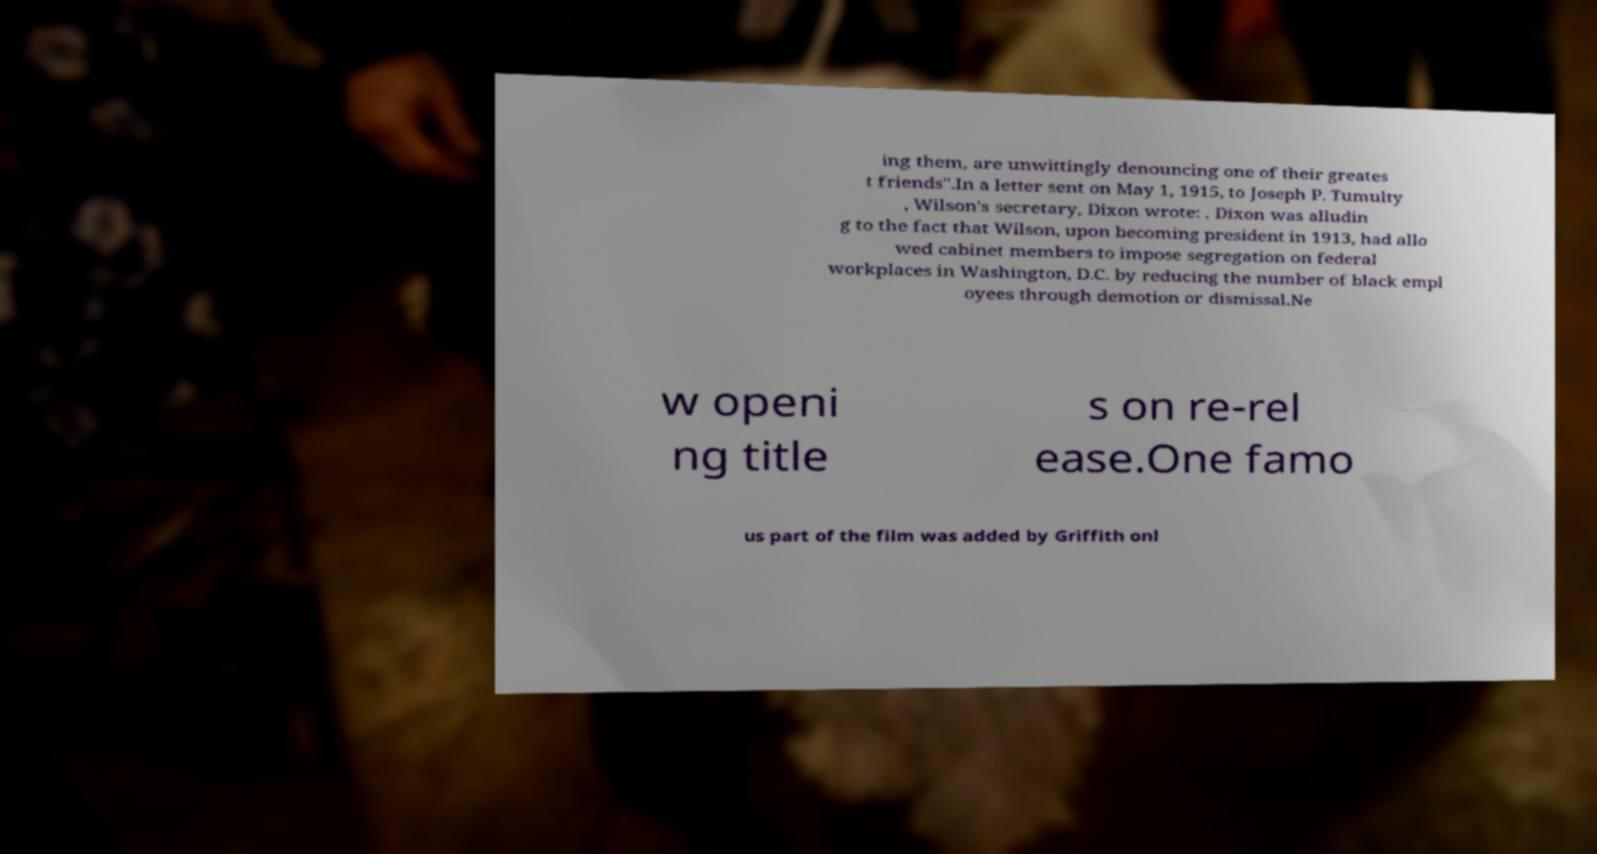Could you assist in decoding the text presented in this image and type it out clearly? ing them, are unwittingly denouncing one of their greates t friends".In a letter sent on May 1, 1915, to Joseph P. Tumulty , Wilson's secretary, Dixon wrote: . Dixon was alludin g to the fact that Wilson, upon becoming president in 1913, had allo wed cabinet members to impose segregation on federal workplaces in Washington, D.C. by reducing the number of black empl oyees through demotion or dismissal.Ne w openi ng title s on re-rel ease.One famo us part of the film was added by Griffith onl 